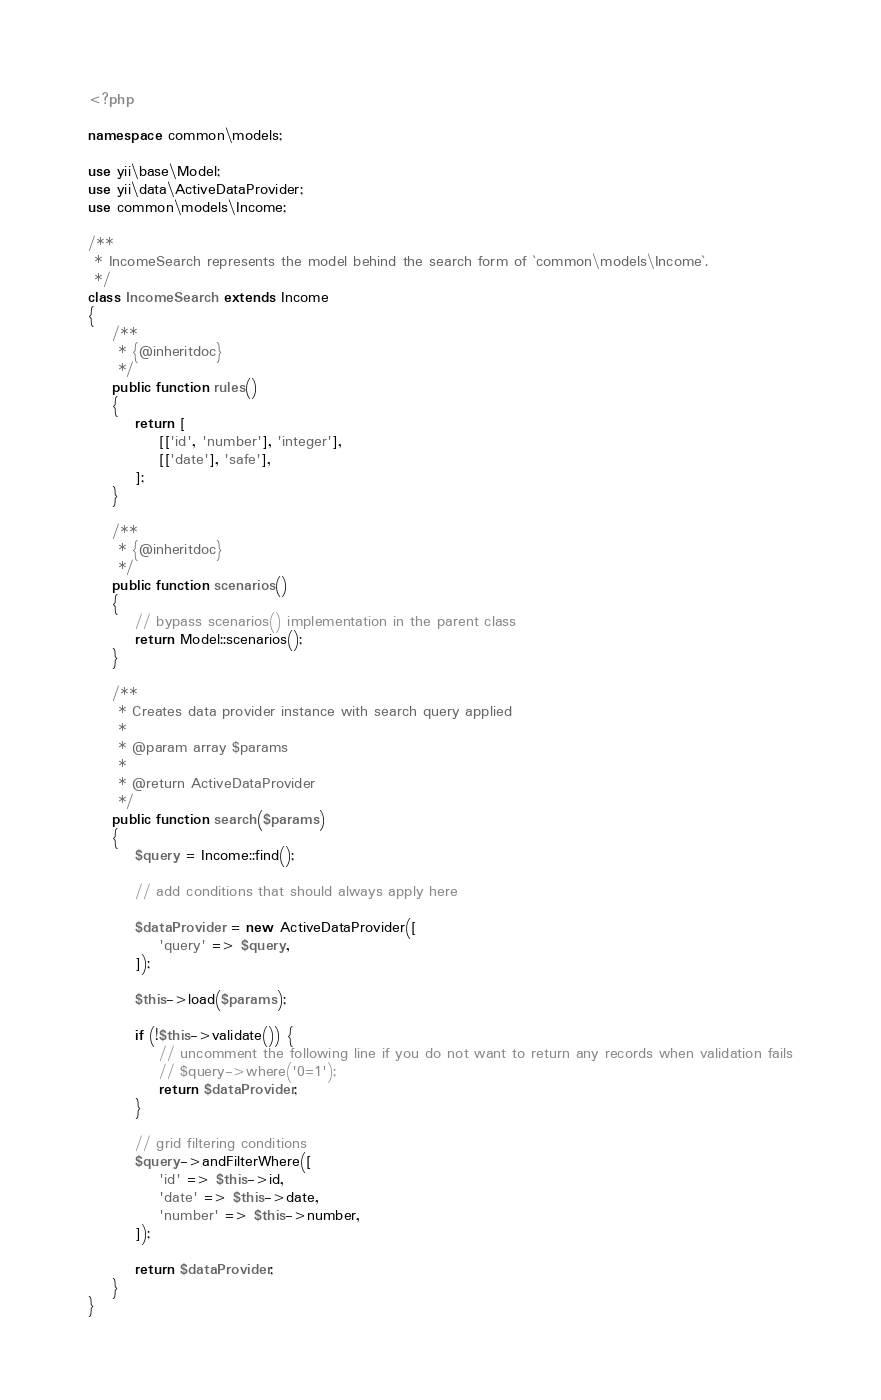Convert code to text. <code><loc_0><loc_0><loc_500><loc_500><_PHP_><?php

namespace common\models;

use yii\base\Model;
use yii\data\ActiveDataProvider;
use common\models\Income;

/**
 * IncomeSearch represents the model behind the search form of `common\models\Income`.
 */
class IncomeSearch extends Income
{
    /**
     * {@inheritdoc}
     */
    public function rules()
    {
        return [
            [['id', 'number'], 'integer'],
            [['date'], 'safe'],
        ];
    }

    /**
     * {@inheritdoc}
     */
    public function scenarios()
    {
        // bypass scenarios() implementation in the parent class
        return Model::scenarios();
    }

    /**
     * Creates data provider instance with search query applied
     *
     * @param array $params
     *
     * @return ActiveDataProvider
     */
    public function search($params)
    {
        $query = Income::find();

        // add conditions that should always apply here

        $dataProvider = new ActiveDataProvider([
            'query' => $query,
        ]);

        $this->load($params);

        if (!$this->validate()) {
            // uncomment the following line if you do not want to return any records when validation fails
            // $query->where('0=1');
            return $dataProvider;
        }

        // grid filtering conditions
        $query->andFilterWhere([
            'id' => $this->id,
            'date' => $this->date,
            'number' => $this->number,
        ]);

        return $dataProvider;
    }
}
</code> 